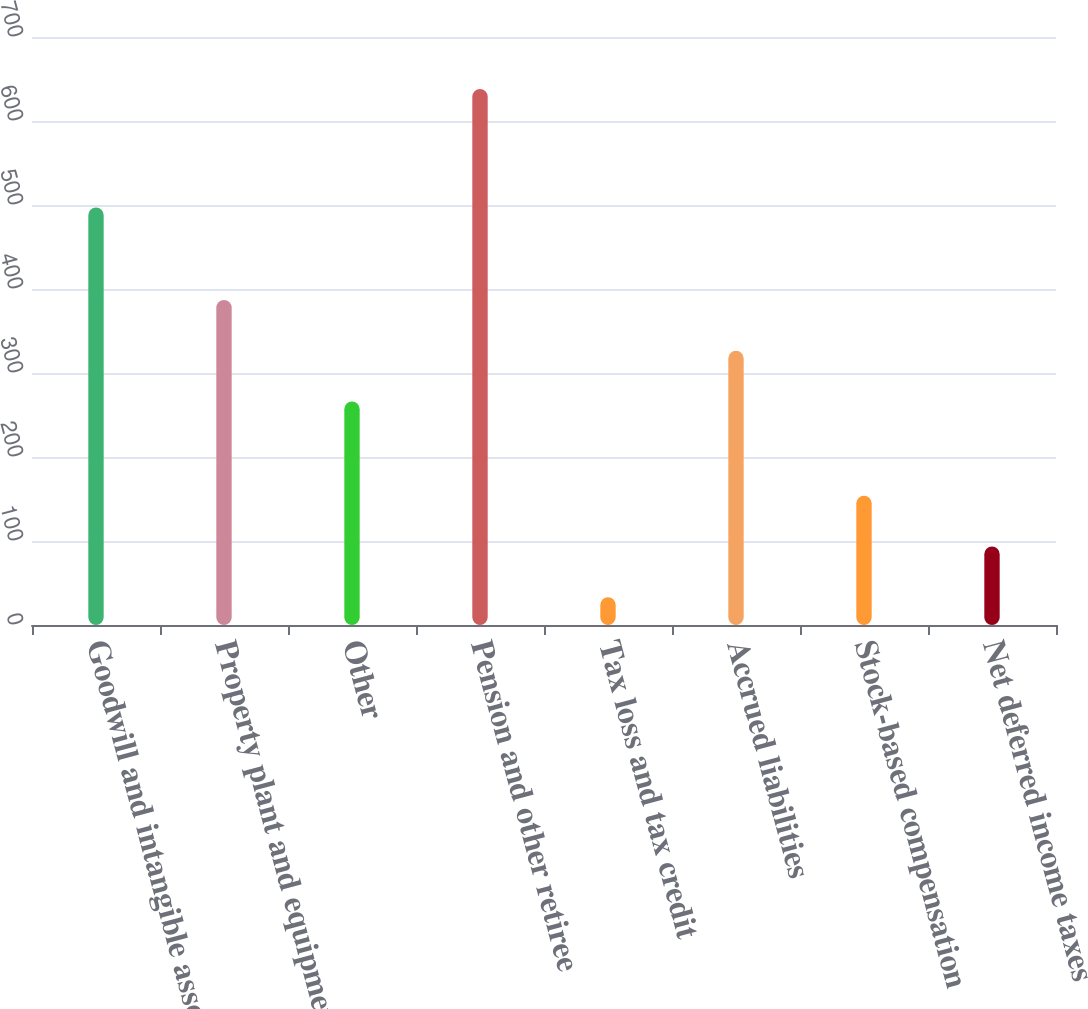Convert chart to OTSL. <chart><loc_0><loc_0><loc_500><loc_500><bar_chart><fcel>Goodwill and intangible assets<fcel>Property plant and equipment<fcel>Other<fcel>Pension and other retiree<fcel>Tax loss and tax credit<fcel>Accrued liabilities<fcel>Stock-based compensation<fcel>Net deferred income taxes<nl><fcel>497<fcel>387<fcel>266<fcel>638<fcel>33<fcel>326.5<fcel>154<fcel>93.5<nl></chart> 